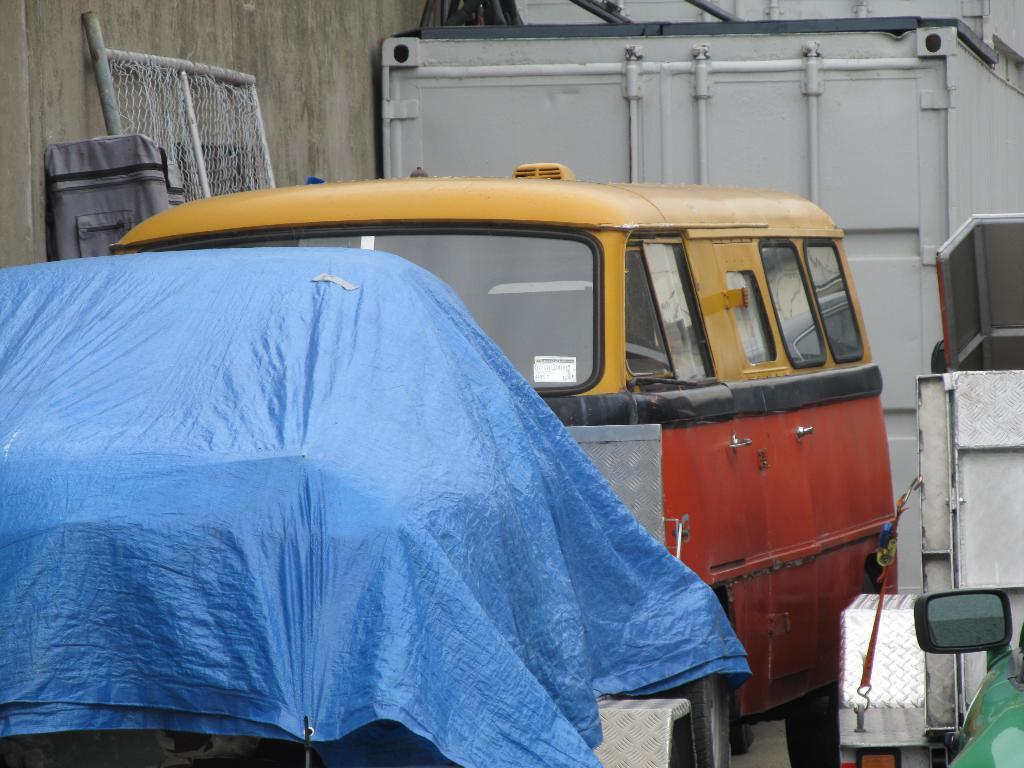What types of vehicles are in the image? There are vehicles in the image, but the specific types are not mentioned. What color is the sheet in the image? The sheet in the image is blue. What can be seen in the image besides vehicles and the blue sheet? There are bags and other objects in the image. How many friends are present in the image? There is no mention of friends in the image, so it cannot be determined how many are present. 